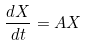<formula> <loc_0><loc_0><loc_500><loc_500>\frac { d X } { d t } = A X</formula> 